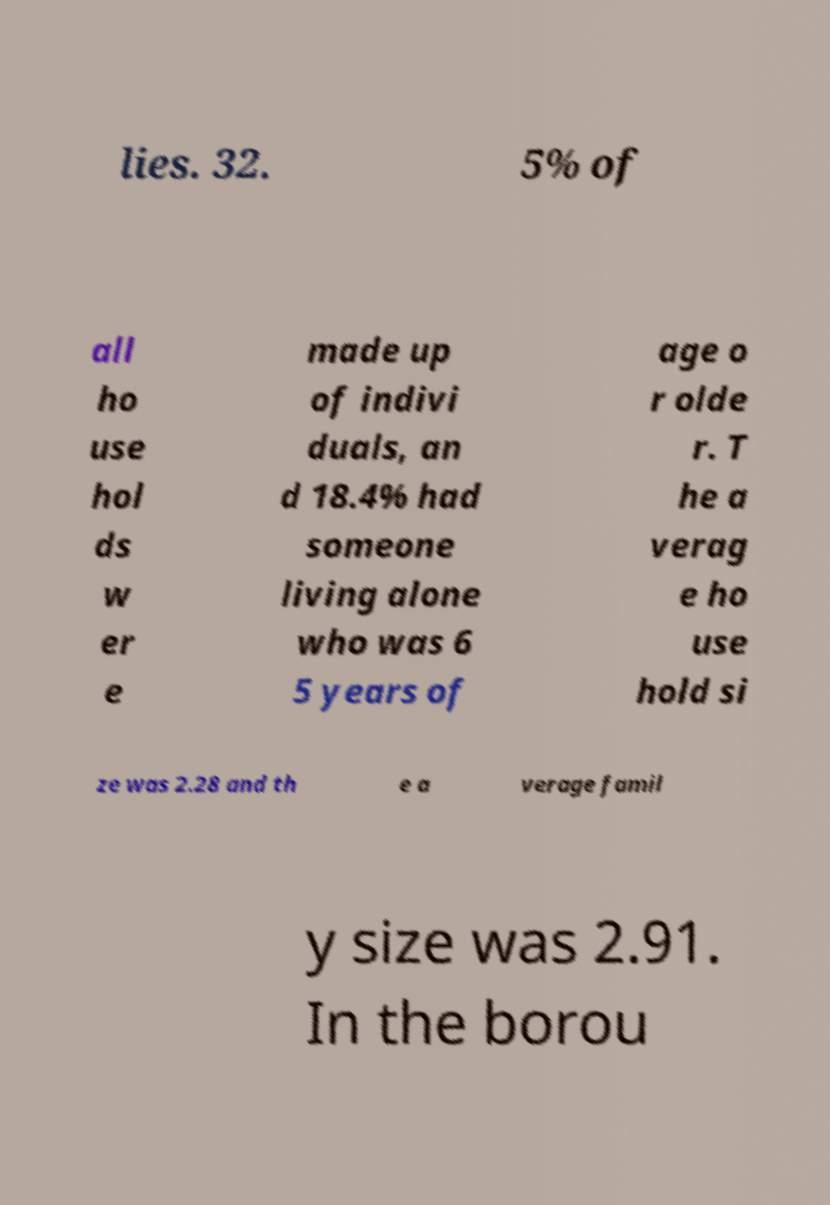I need the written content from this picture converted into text. Can you do that? lies. 32. 5% of all ho use hol ds w er e made up of indivi duals, an d 18.4% had someone living alone who was 6 5 years of age o r olde r. T he a verag e ho use hold si ze was 2.28 and th e a verage famil y size was 2.91. In the borou 